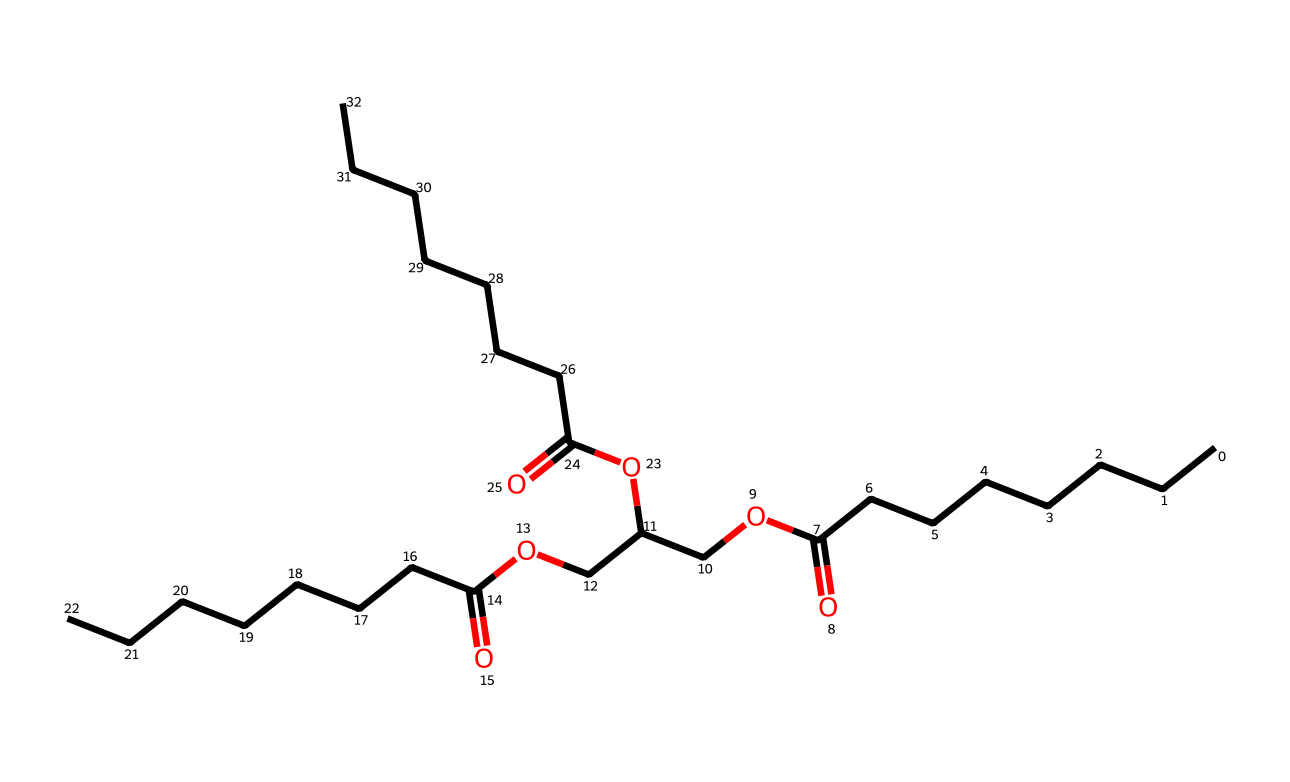What is the primary functional group in this chemical structure? The presence of the carboxylic acid functional group (-COOH) indicates that the primary functional group in this chemical structure is carboxylic acid. You can identify this by looking for the carbon atom double-bonded to an oxygen atom and single-bonded to a hydroxyl group (-OH).
Answer: carboxylic acid How many carbon atoms are present in the structure? To find the total number of carbon atoms, we can count the 'C' atoms in the SMILES representation. Here, there are 21 carbon atoms in total: 7 from each of the three straight carbon chains and 1 shared in the ester groups.
Answer: 21 What type of lipid does this chemical belong to based on its structure? This chemical structure represents a type of lipid known as an ester due to the presence of ester linkages (RCOOR') linking carbon chains. This can be observed where carbon atoms are bonded through an ester bond.
Answer: ester How many ester bonds can be identified in this chemical? The structure contains three ester linkages where the acid and alcohol components are connected. Each ester bond can be identified where a carbon atom of an acid is linked to an oxygen atom that is also connected to another carbon chain.
Answer: 3 What is the relationship between this chemical and biodegradable properties? The structure contains multiple ester bonds and long-chain fatty acid derivatives, making it a candidate for biodegradability due to the susceptibility of ester linkages to hydrolysis by microbes, resulting in simpler and less harmful compounds.
Answer: biodegradable 